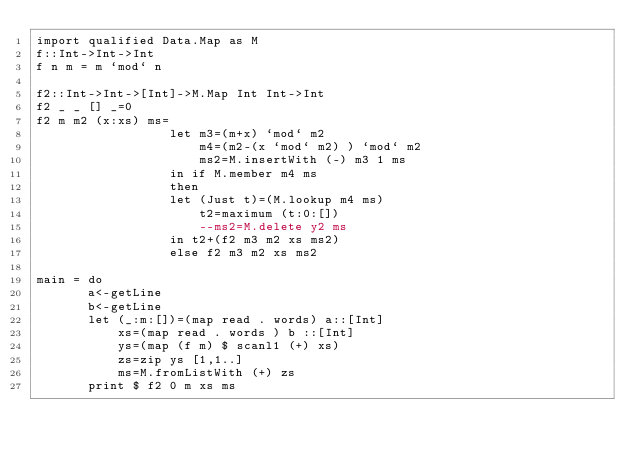Convert code to text. <code><loc_0><loc_0><loc_500><loc_500><_Haskell_>import qualified Data.Map as M
f::Int->Int->Int
f n m = m `mod` n 

f2::Int->Int->[Int]->M.Map Int Int->Int
f2 _ _ [] _=0
f2 m m2 (x:xs) ms=
                  let m3=(m+x) `mod` m2
                      m4=(m2-(x `mod` m2) ) `mod` m2
                      ms2=M.insertWith (-) m3 1 ms
                  in if M.member m4 ms
                  then 
                  let (Just t)=(M.lookup m4 ms)
                      t2=maximum (t:0:[])
                      --ms2=M.delete y2 ms
                  in t2+(f2 m3 m2 xs ms2)
                  else f2 m3 m2 xs ms2

main = do
       a<-getLine
       b<-getLine
       let (_:m:[])=(map read . words) a::[Int]
           xs=(map read . words ) b ::[Int]
           ys=(map (f m) $ scanl1 (+) xs)
           zs=zip ys [1,1..]
           ms=M.fromListWith (+) zs
       print $ f2 0 m xs ms</code> 